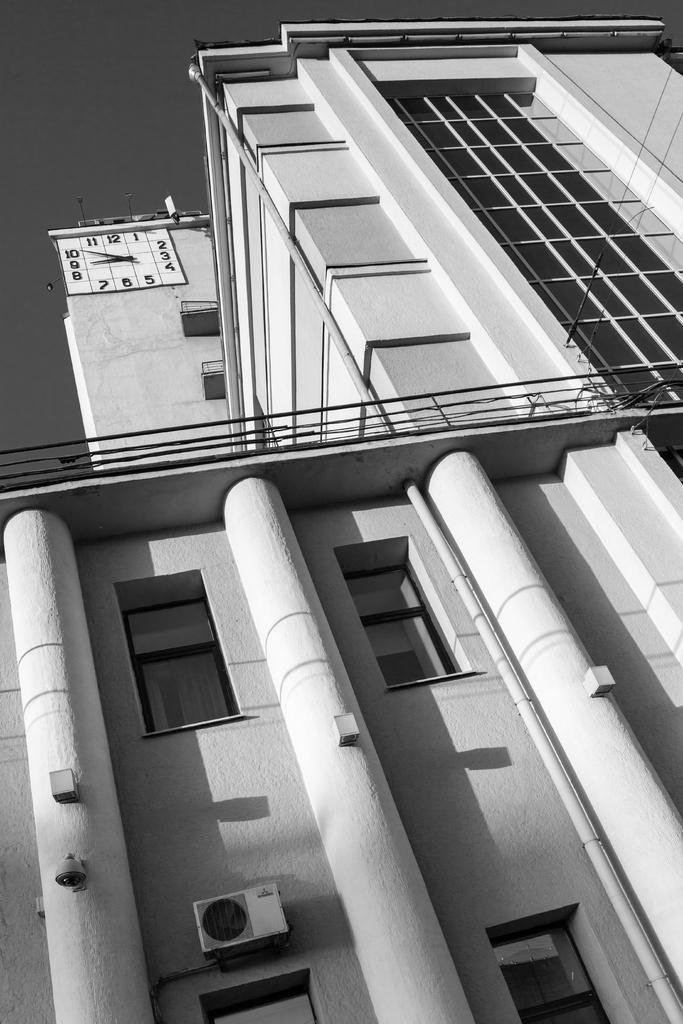How would you summarize this image in a sentence or two? In the picture we can see the building with windows and glasses and on the top of the building we can see a clock to the wall. 